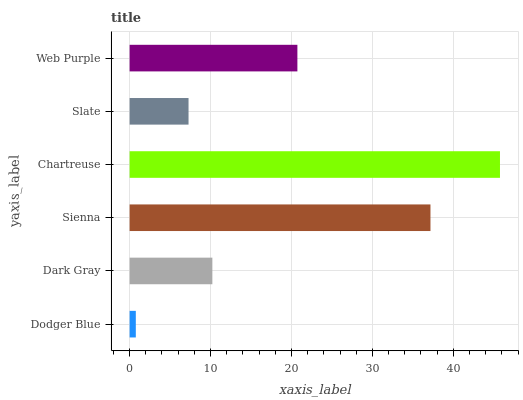Is Dodger Blue the minimum?
Answer yes or no. Yes. Is Chartreuse the maximum?
Answer yes or no. Yes. Is Dark Gray the minimum?
Answer yes or no. No. Is Dark Gray the maximum?
Answer yes or no. No. Is Dark Gray greater than Dodger Blue?
Answer yes or no. Yes. Is Dodger Blue less than Dark Gray?
Answer yes or no. Yes. Is Dodger Blue greater than Dark Gray?
Answer yes or no. No. Is Dark Gray less than Dodger Blue?
Answer yes or no. No. Is Web Purple the high median?
Answer yes or no. Yes. Is Dark Gray the low median?
Answer yes or no. Yes. Is Sienna the high median?
Answer yes or no. No. Is Slate the low median?
Answer yes or no. No. 